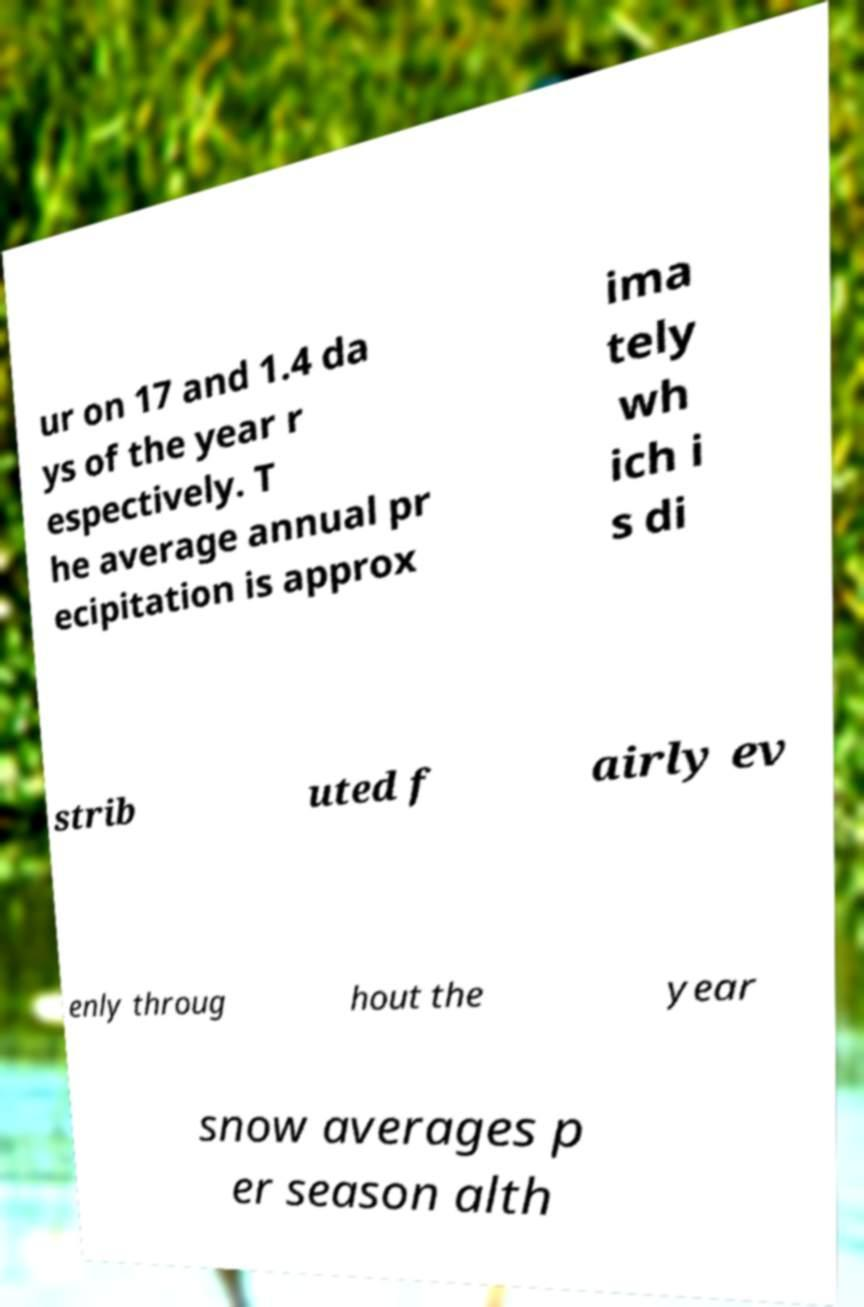Could you extract and type out the text from this image? ur on 17 and 1.4 da ys of the year r espectively. T he average annual pr ecipitation is approx ima tely wh ich i s di strib uted f airly ev enly throug hout the year snow averages p er season alth 